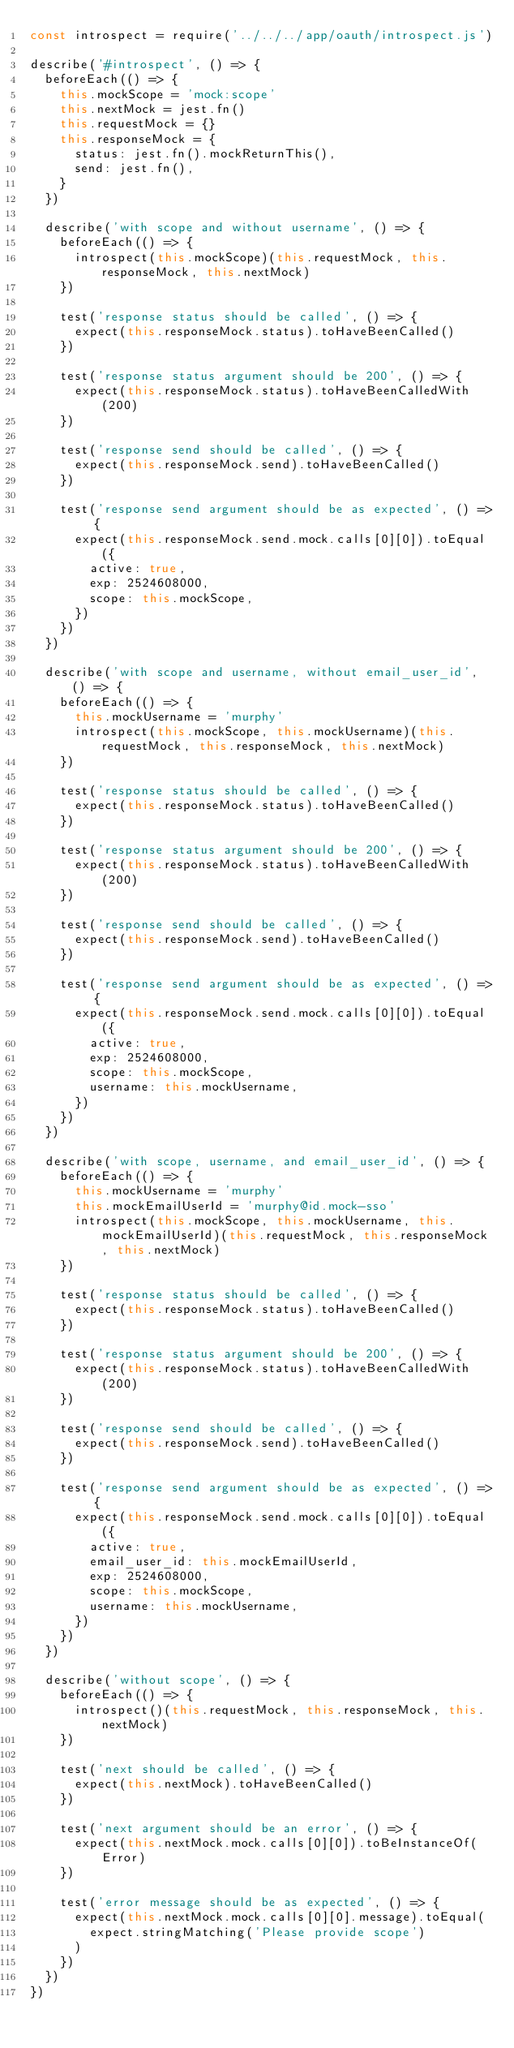<code> <loc_0><loc_0><loc_500><loc_500><_JavaScript_>const introspect = require('../../../app/oauth/introspect.js')

describe('#introspect', () => {
  beforeEach(() => {
    this.mockScope = 'mock:scope'
    this.nextMock = jest.fn()
    this.requestMock = {}
    this.responseMock = {
      status: jest.fn().mockReturnThis(),
      send: jest.fn(),
    }
  })

  describe('with scope and without username', () => {
    beforeEach(() => {
      introspect(this.mockScope)(this.requestMock, this.responseMock, this.nextMock)
    })

    test('response status should be called', () => {
      expect(this.responseMock.status).toHaveBeenCalled()
    })

    test('response status argument should be 200', () => {
      expect(this.responseMock.status).toHaveBeenCalledWith(200)
    })

    test('response send should be called', () => {
      expect(this.responseMock.send).toHaveBeenCalled()
    })

    test('response send argument should be as expected', () => {
      expect(this.responseMock.send.mock.calls[0][0]).toEqual({
        active: true,
        exp: 2524608000,
        scope: this.mockScope,
      })
    })
  })

  describe('with scope and username, without email_user_id', () => {
    beforeEach(() => {
      this.mockUsername = 'murphy'
      introspect(this.mockScope, this.mockUsername)(this.requestMock, this.responseMock, this.nextMock)
    })

    test('response status should be called', () => {
      expect(this.responseMock.status).toHaveBeenCalled()
    })

    test('response status argument should be 200', () => {
      expect(this.responseMock.status).toHaveBeenCalledWith(200)
    })

    test('response send should be called', () => {
      expect(this.responseMock.send).toHaveBeenCalled()
    })

    test('response send argument should be as expected', () => {
      expect(this.responseMock.send.mock.calls[0][0]).toEqual({
        active: true,
        exp: 2524608000,
        scope: this.mockScope,
        username: this.mockUsername,
      })
    })
  })

  describe('with scope, username, and email_user_id', () => {
    beforeEach(() => {
      this.mockUsername = 'murphy'
      this.mockEmailUserId = 'murphy@id.mock-sso'
      introspect(this.mockScope, this.mockUsername, this.mockEmailUserId)(this.requestMock, this.responseMock, this.nextMock)
    })

    test('response status should be called', () => {
      expect(this.responseMock.status).toHaveBeenCalled()
    })

    test('response status argument should be 200', () => {
      expect(this.responseMock.status).toHaveBeenCalledWith(200)
    })

    test('response send should be called', () => {
      expect(this.responseMock.send).toHaveBeenCalled()
    })

    test('response send argument should be as expected', () => {
      expect(this.responseMock.send.mock.calls[0][0]).toEqual({
        active: true,
        email_user_id: this.mockEmailUserId,
        exp: 2524608000,
        scope: this.mockScope,
        username: this.mockUsername,
      })
    })
  })

  describe('without scope', () => {
    beforeEach(() => {
      introspect()(this.requestMock, this.responseMock, this.nextMock)
    })

    test('next should be called', () => {
      expect(this.nextMock).toHaveBeenCalled()
    })

    test('next argument should be an error', () => {
      expect(this.nextMock.mock.calls[0][0]).toBeInstanceOf(Error)
    })

    test('error message should be as expected', () => {
      expect(this.nextMock.mock.calls[0][0].message).toEqual(
        expect.stringMatching('Please provide scope')
      )
    })
  })
})
</code> 